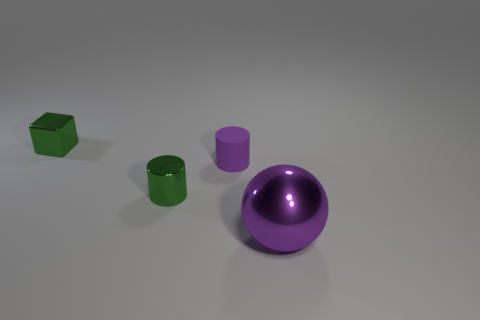Add 1 purple cylinders. How many objects exist? 5 Subtract all cubes. How many objects are left? 3 Add 2 tiny cubes. How many tiny cubes exist? 3 Subtract 0 red balls. How many objects are left? 4 Subtract all spheres. Subtract all large purple balls. How many objects are left? 2 Add 1 small purple matte objects. How many small purple matte objects are left? 2 